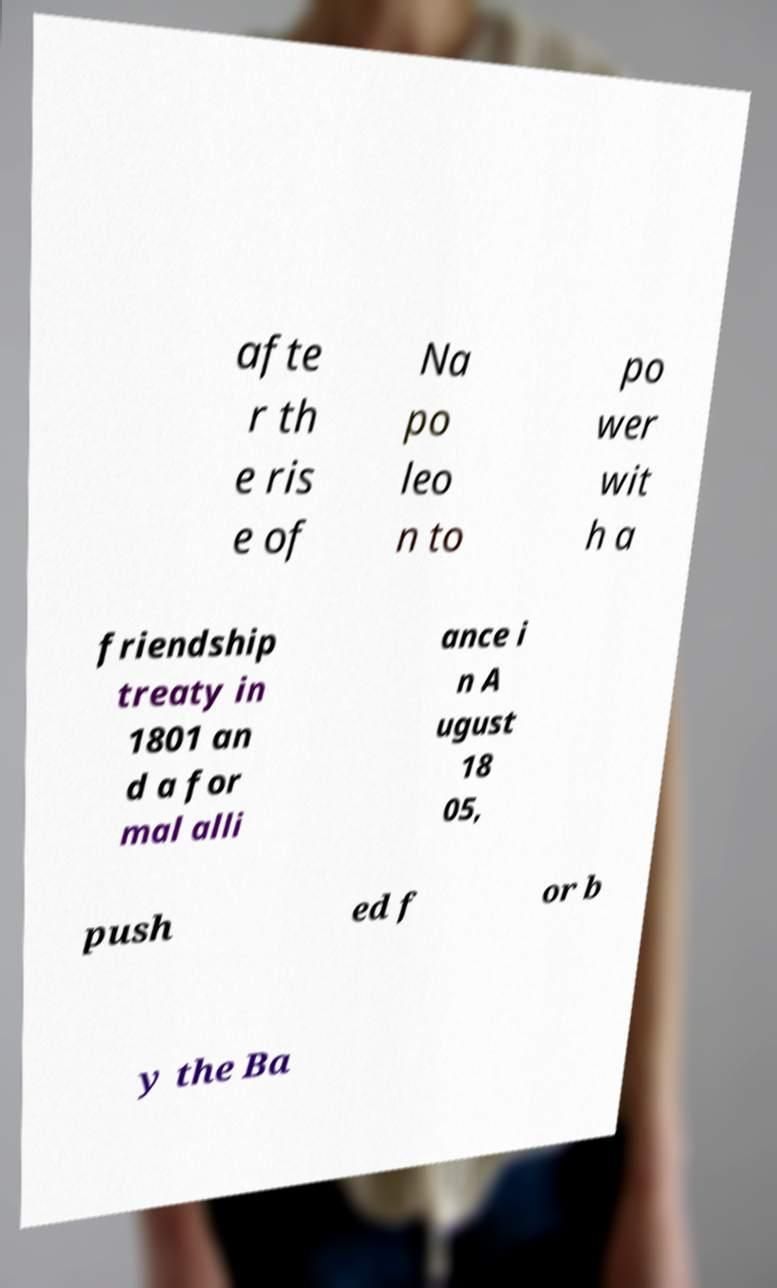Please identify and transcribe the text found in this image. afte r th e ris e of Na po leo n to po wer wit h a friendship treaty in 1801 an d a for mal alli ance i n A ugust 18 05, push ed f or b y the Ba 